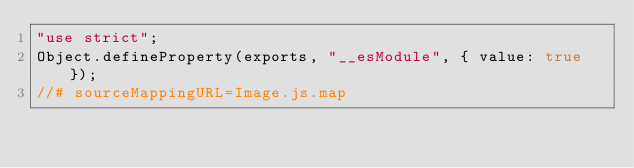<code> <loc_0><loc_0><loc_500><loc_500><_JavaScript_>"use strict";
Object.defineProperty(exports, "__esModule", { value: true });
//# sourceMappingURL=Image.js.map</code> 